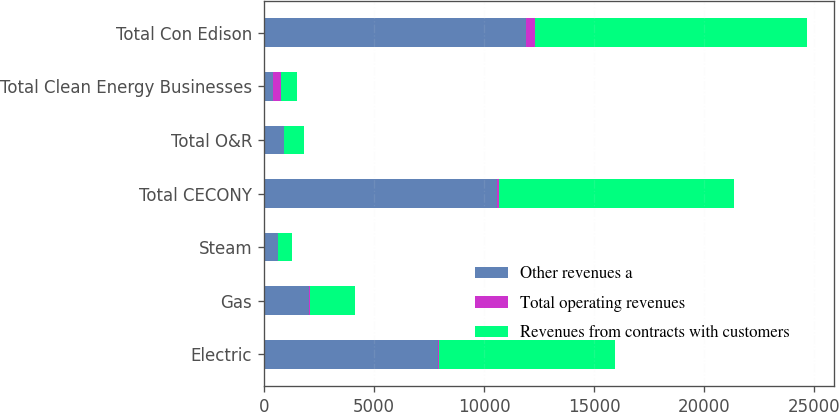Convert chart. <chart><loc_0><loc_0><loc_500><loc_500><stacked_bar_chart><ecel><fcel>Electric<fcel>Gas<fcel>Steam<fcel>Total CECONY<fcel>Total O&R<fcel>Total Clean Energy Businesses<fcel>Total Con Edison<nl><fcel>Other revenues a<fcel>7920<fcel>2052<fcel>625<fcel>10597<fcel>903<fcel>424<fcel>11928<nl><fcel>Total operating revenues<fcel>51<fcel>26<fcel>6<fcel>83<fcel>12<fcel>339<fcel>409<nl><fcel>Revenues from contracts with customers<fcel>7971<fcel>2078<fcel>631<fcel>10680<fcel>891<fcel>763<fcel>12337<nl></chart> 